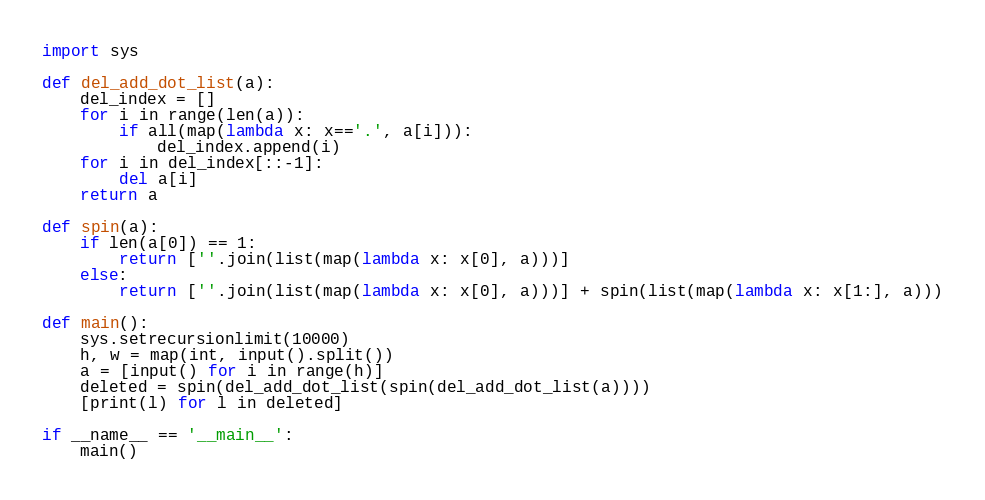<code> <loc_0><loc_0><loc_500><loc_500><_Python_>import sys

def del_add_dot_list(a):
    del_index = []
    for i in range(len(a)):
        if all(map(lambda x: x=='.', a[i])):
            del_index.append(i)
    for i in del_index[::-1]:
        del a[i]
    return a

def spin(a):
    if len(a[0]) == 1:
        return [''.join(list(map(lambda x: x[0], a)))]
    else:
        return [''.join(list(map(lambda x: x[0], a)))] + spin(list(map(lambda x: x[1:], a)))

def main():
    sys.setrecursionlimit(10000)
    h, w = map(int, input().split())
    a = [input() for i in range(h)]
    deleted = spin(del_add_dot_list(spin(del_add_dot_list(a))))
    [print(l) for l in deleted]

if __name__ == '__main__':
    main()</code> 